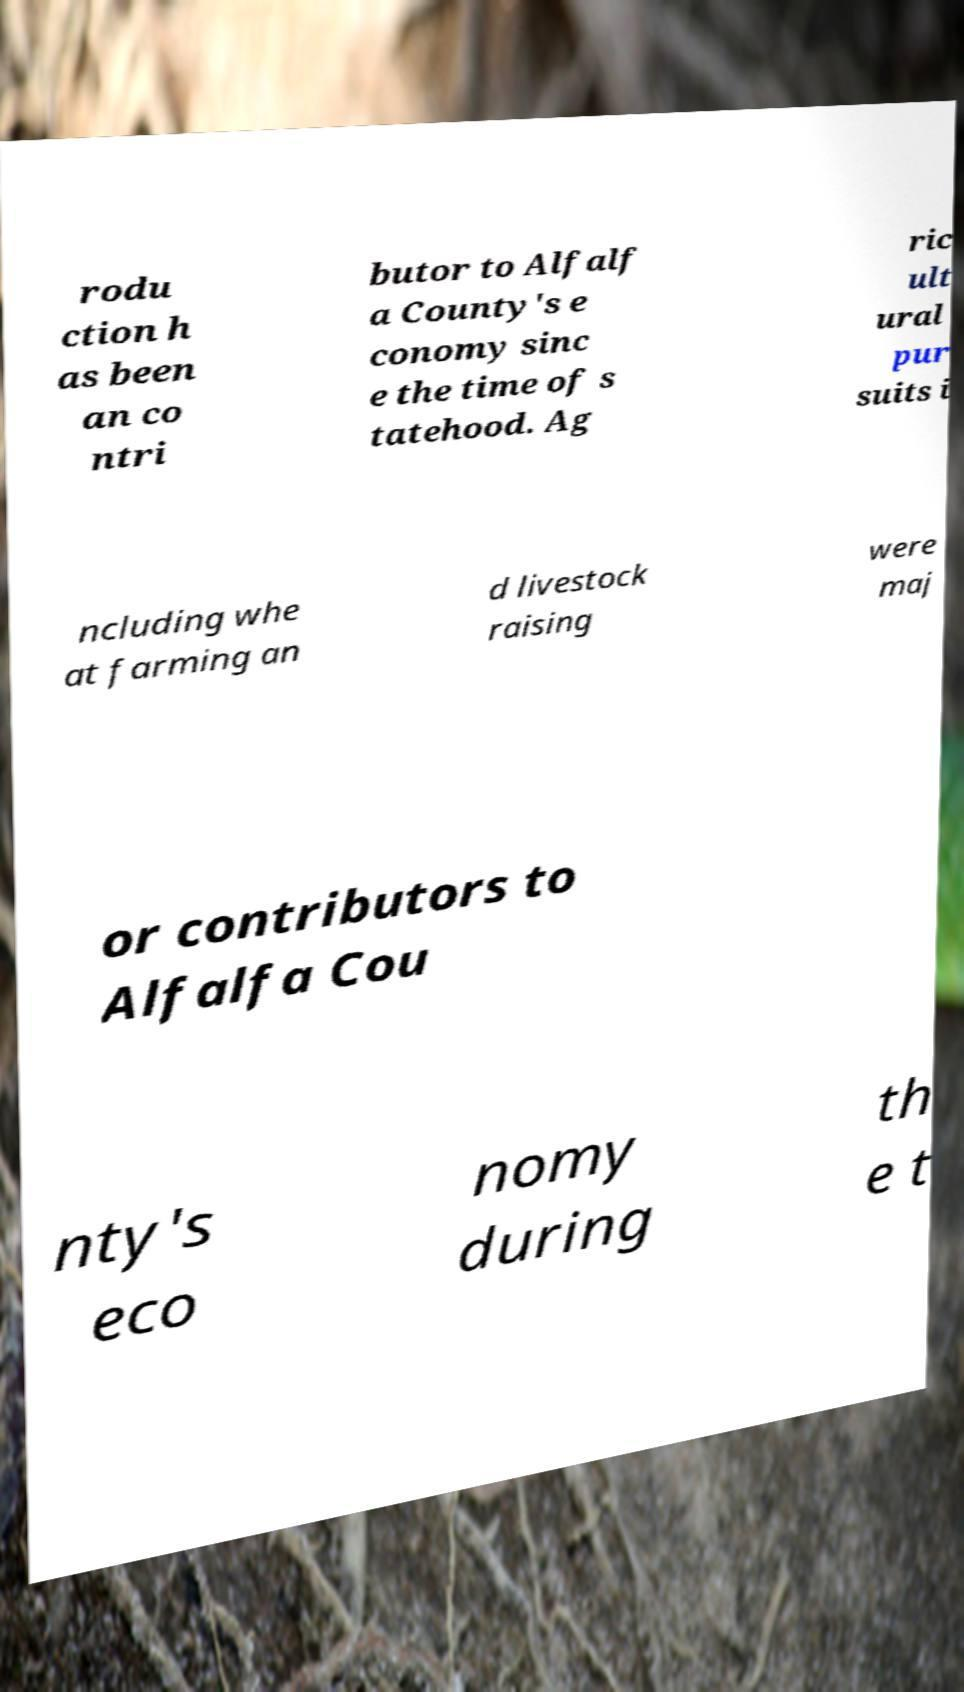What messages or text are displayed in this image? I need them in a readable, typed format. rodu ction h as been an co ntri butor to Alfalf a County's e conomy sinc e the time of s tatehood. Ag ric ult ural pur suits i ncluding whe at farming an d livestock raising were maj or contributors to Alfalfa Cou nty's eco nomy during th e t 